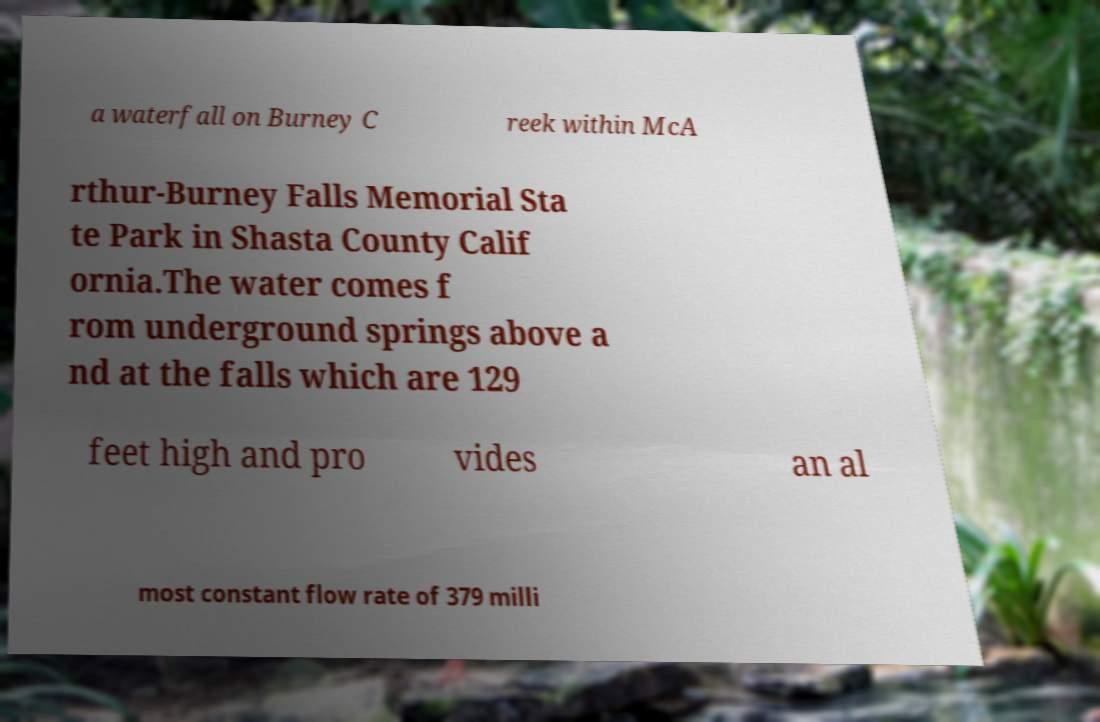Please identify and transcribe the text found in this image. a waterfall on Burney C reek within McA rthur-Burney Falls Memorial Sta te Park in Shasta County Calif ornia.The water comes f rom underground springs above a nd at the falls which are 129 feet high and pro vides an al most constant flow rate of 379 milli 